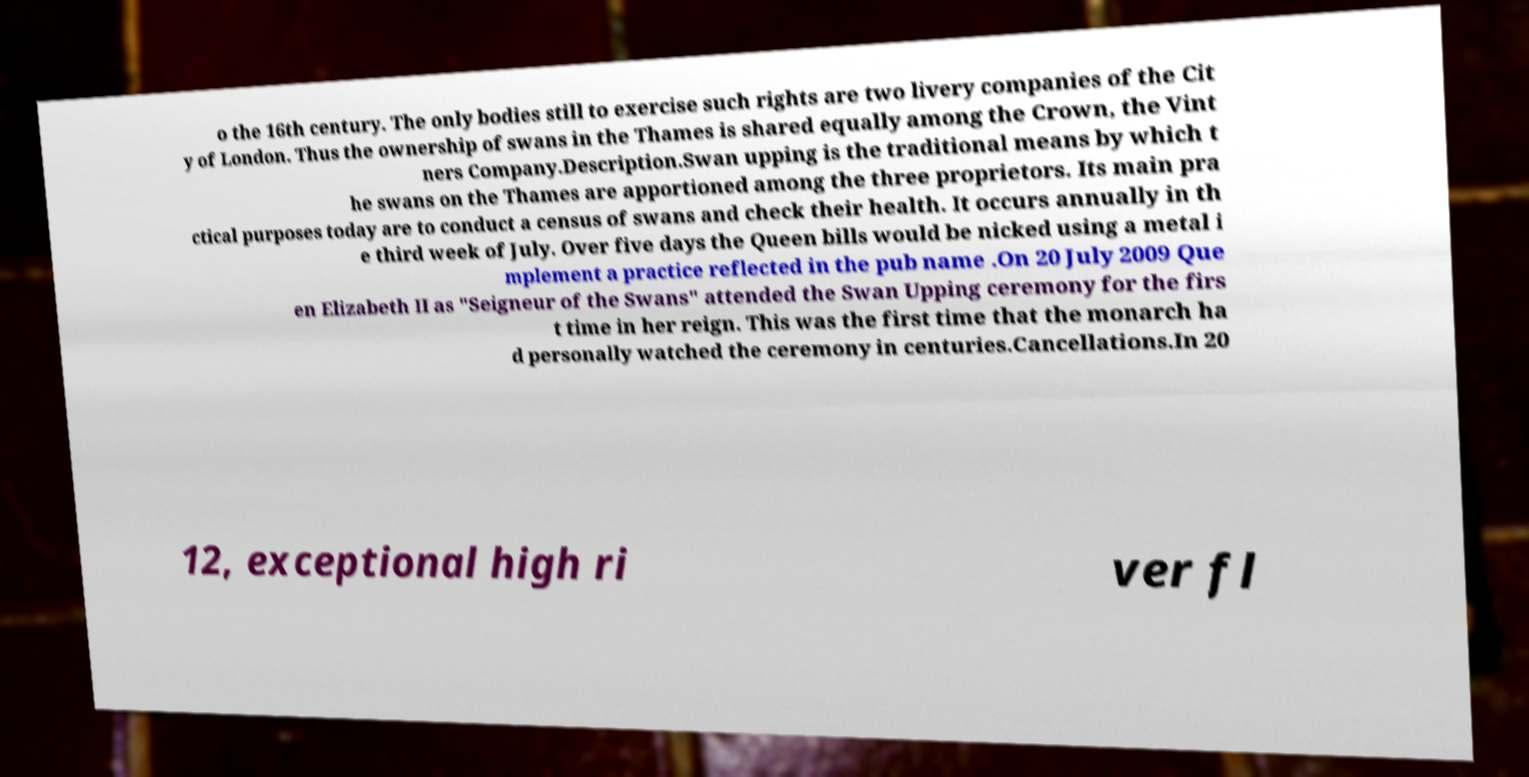Please identify and transcribe the text found in this image. o the 16th century. The only bodies still to exercise such rights are two livery companies of the Cit y of London. Thus the ownership of swans in the Thames is shared equally among the Crown, the Vint ners Company.Description.Swan upping is the traditional means by which t he swans on the Thames are apportioned among the three proprietors. Its main pra ctical purposes today are to conduct a census of swans and check their health. It occurs annually in th e third week of July. Over five days the Queen bills would be nicked using a metal i mplement a practice reflected in the pub name .On 20 July 2009 Que en Elizabeth II as "Seigneur of the Swans" attended the Swan Upping ceremony for the firs t time in her reign. This was the first time that the monarch ha d personally watched the ceremony in centuries.Cancellations.In 20 12, exceptional high ri ver fl 